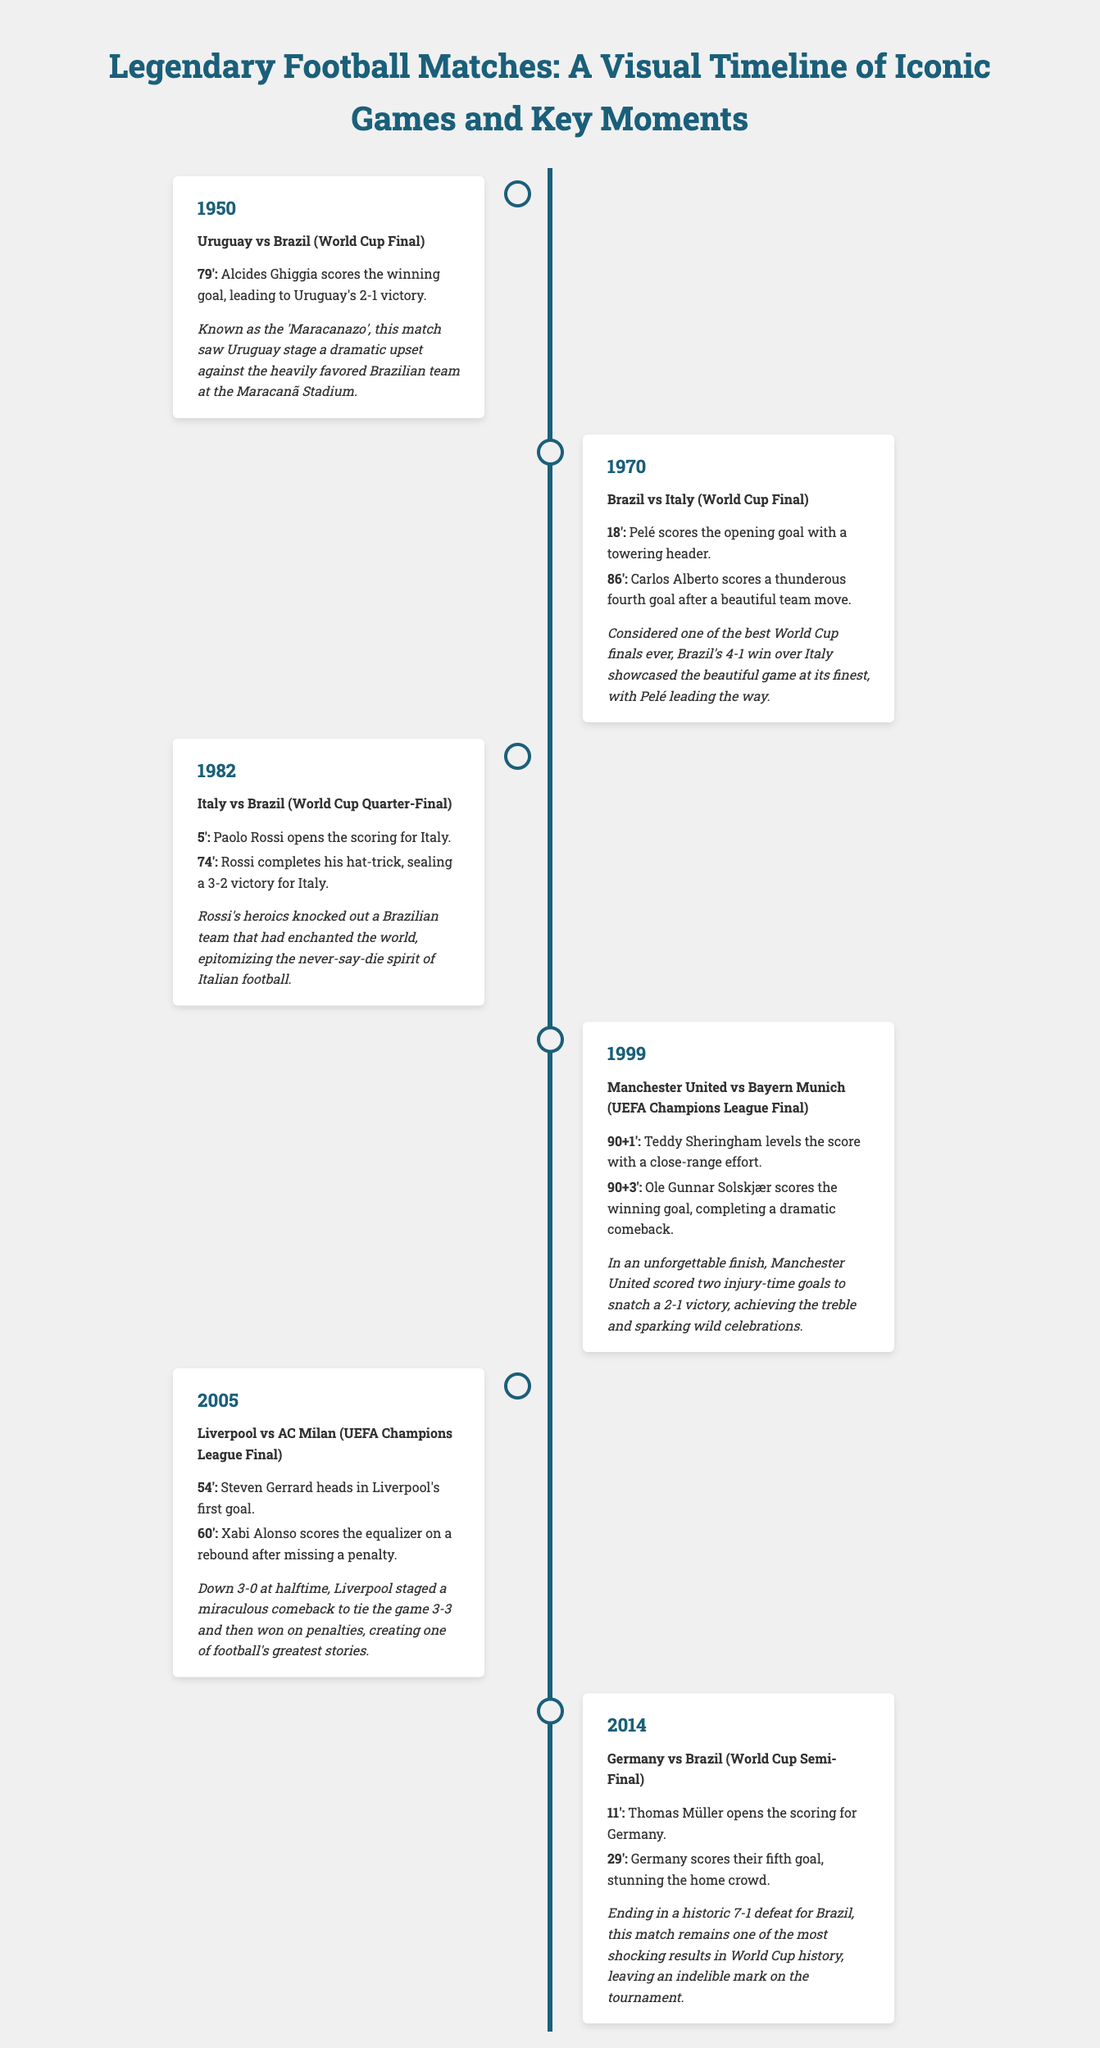What year did Uruguay defeat Brazil in the World Cup Final? The year of Uruguay's victory over Brazil is clearly stated in the timeline as 1950.
Answer: 1950 Who scored the winning goal in the 1999 UEFA Champions League Final? The timeline mentions Ole Gunnar Solskjær as the player who scored the winning goal.
Answer: Ole Gunnar Solskjær How many goals did Germany score against Brazil in the 2014 World Cup Semi-Final? The timeline notes that Germany scored a total of seven goals during this match.
Answer: 7 What was the final score of the 2005 UEFA Champions League Final? The timeline indicates that Liverpool and AC Milan ended the match in a 3-3 draw before Liverpool won on penalties.
Answer: 3-3 Which player opened the scoring for Brazil in the 1970 World Cup Final? The key moment mentions Pelé as the player who scored the opening goal in the match.
Answer: Pelé What was the dramatic comeback score for Liverpool in the 2005 UEFA Champions League Final? The description explains that Liverpool came back from being down 3-0 to tie the match at 3-3.
Answer: 3-3 In which match did Paolo Rossi complete a hat-trick? The timeline specifies that Rossi completed his hat-trick in the 1982 World Cup Quarter-Final against Brazil.
Answer: 1982 What notable event is referred to as the 'Maracanazo'? The document describes Uruguay's victory over Brazil in the 1950 World Cup Final as the 'Maracanazo'.
Answer: 'Maracanazo' What was the score of Brazil vs Italy in the 1970 World Cup Final? The timeline details that Brazil won the final match against Italy with a score of 4-1.
Answer: 4-1 